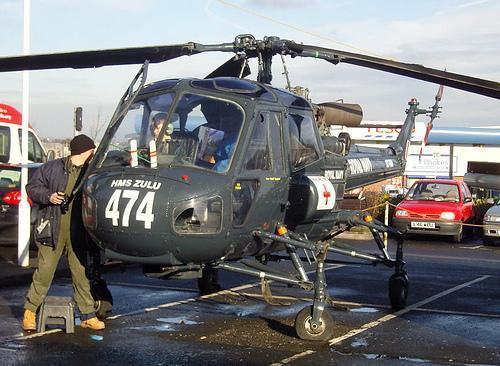How many helicopters?
Give a very brief answer. 1. How many people?
Give a very brief answer. 2. 